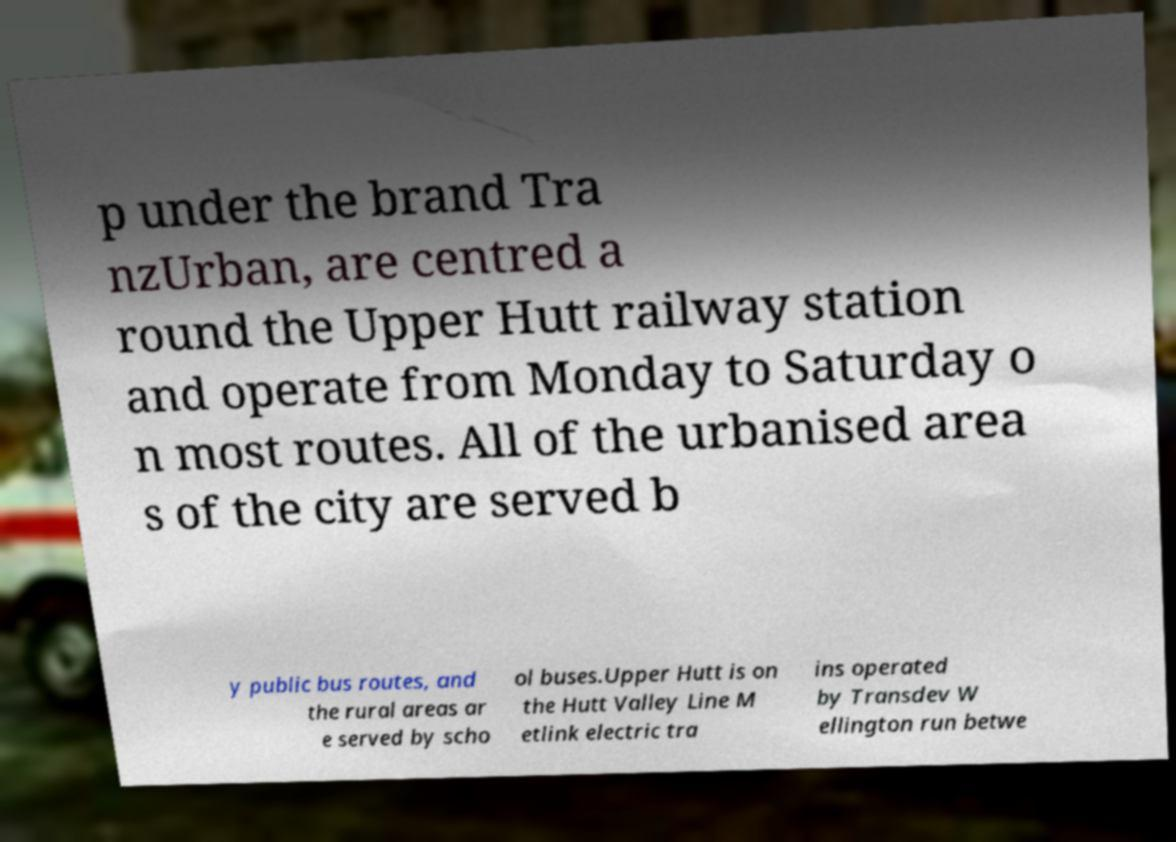Could you assist in decoding the text presented in this image and type it out clearly? p under the brand Tra nzUrban, are centred a round the Upper Hutt railway station and operate from Monday to Saturday o n most routes. All of the urbanised area s of the city are served b y public bus routes, and the rural areas ar e served by scho ol buses.Upper Hutt is on the Hutt Valley Line M etlink electric tra ins operated by Transdev W ellington run betwe 